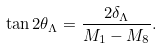Convert formula to latex. <formula><loc_0><loc_0><loc_500><loc_500>\tan 2 \theta _ { \Lambda } = \frac { 2 \delta _ { \Lambda } } { M _ { 1 } - M _ { 8 } } .</formula> 